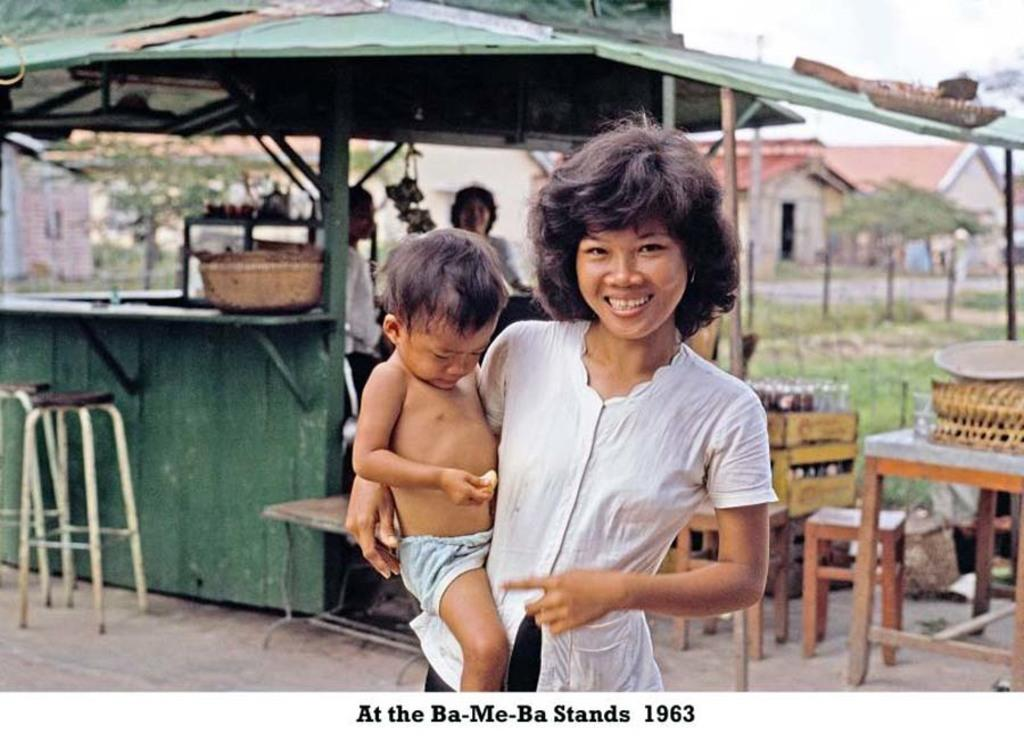Who is the main subject in the image? There is a woman in the image. What is the woman doing in the image? The woman is holding a baby. What is the woman's expression in the image? The woman is smiling. What can be seen in the background of the image? There is a tent, stools, tables, and trees in the background of the image. What is on the table in the image? There are boxes and other items on the table in the image. What type of beast can be seen interacting with the woman and baby in the image? There is no beast present in the image; it features a woman holding a baby. What is the heart rate of the baby in the image? There is no information about the baby's heart rate in the image. 